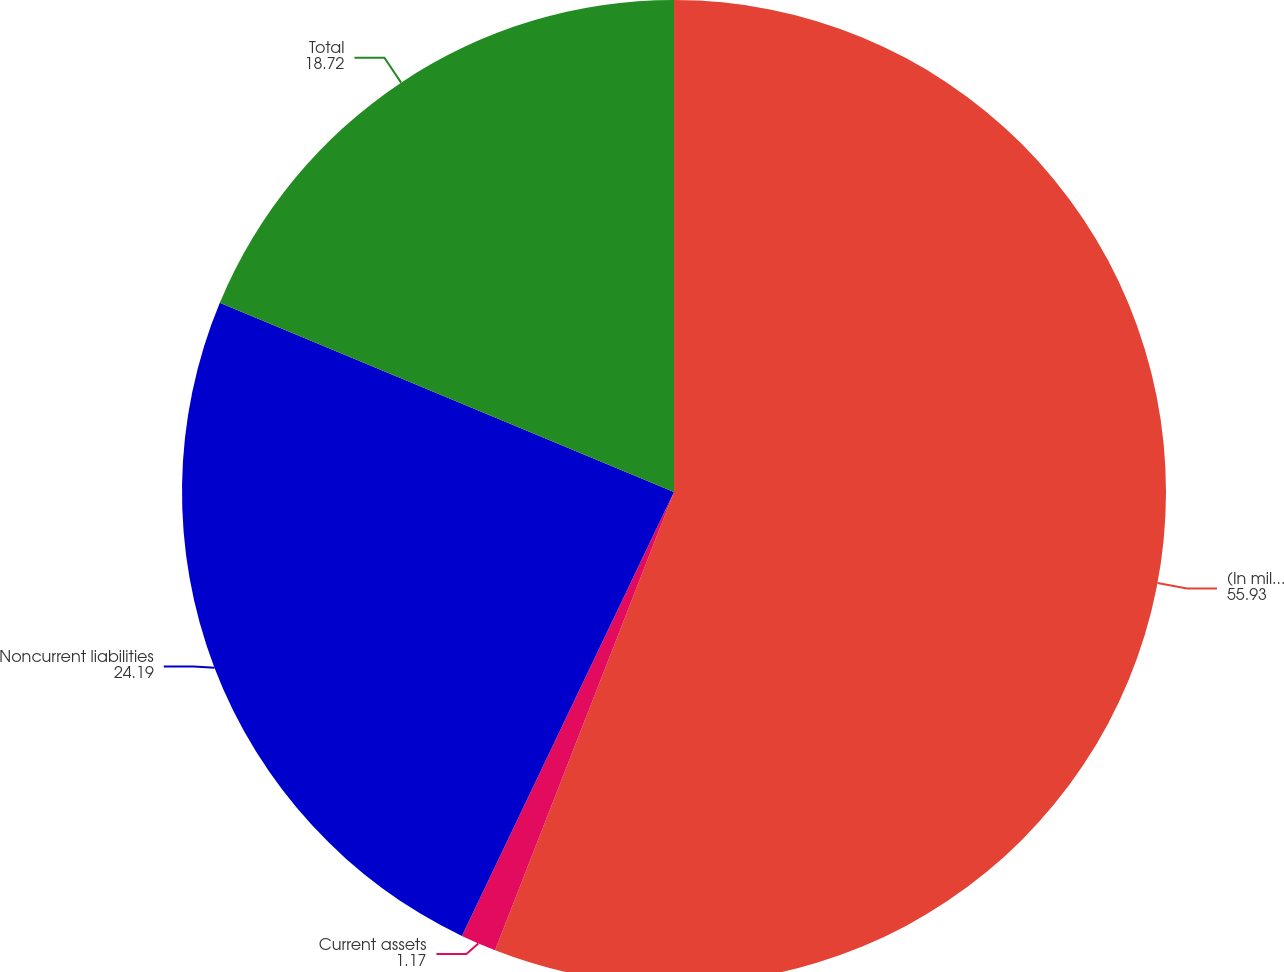<chart> <loc_0><loc_0><loc_500><loc_500><pie_chart><fcel>(In millions)<fcel>Current assets<fcel>Noncurrent liabilities<fcel>Total<nl><fcel>55.93%<fcel>1.17%<fcel>24.19%<fcel>18.72%<nl></chart> 